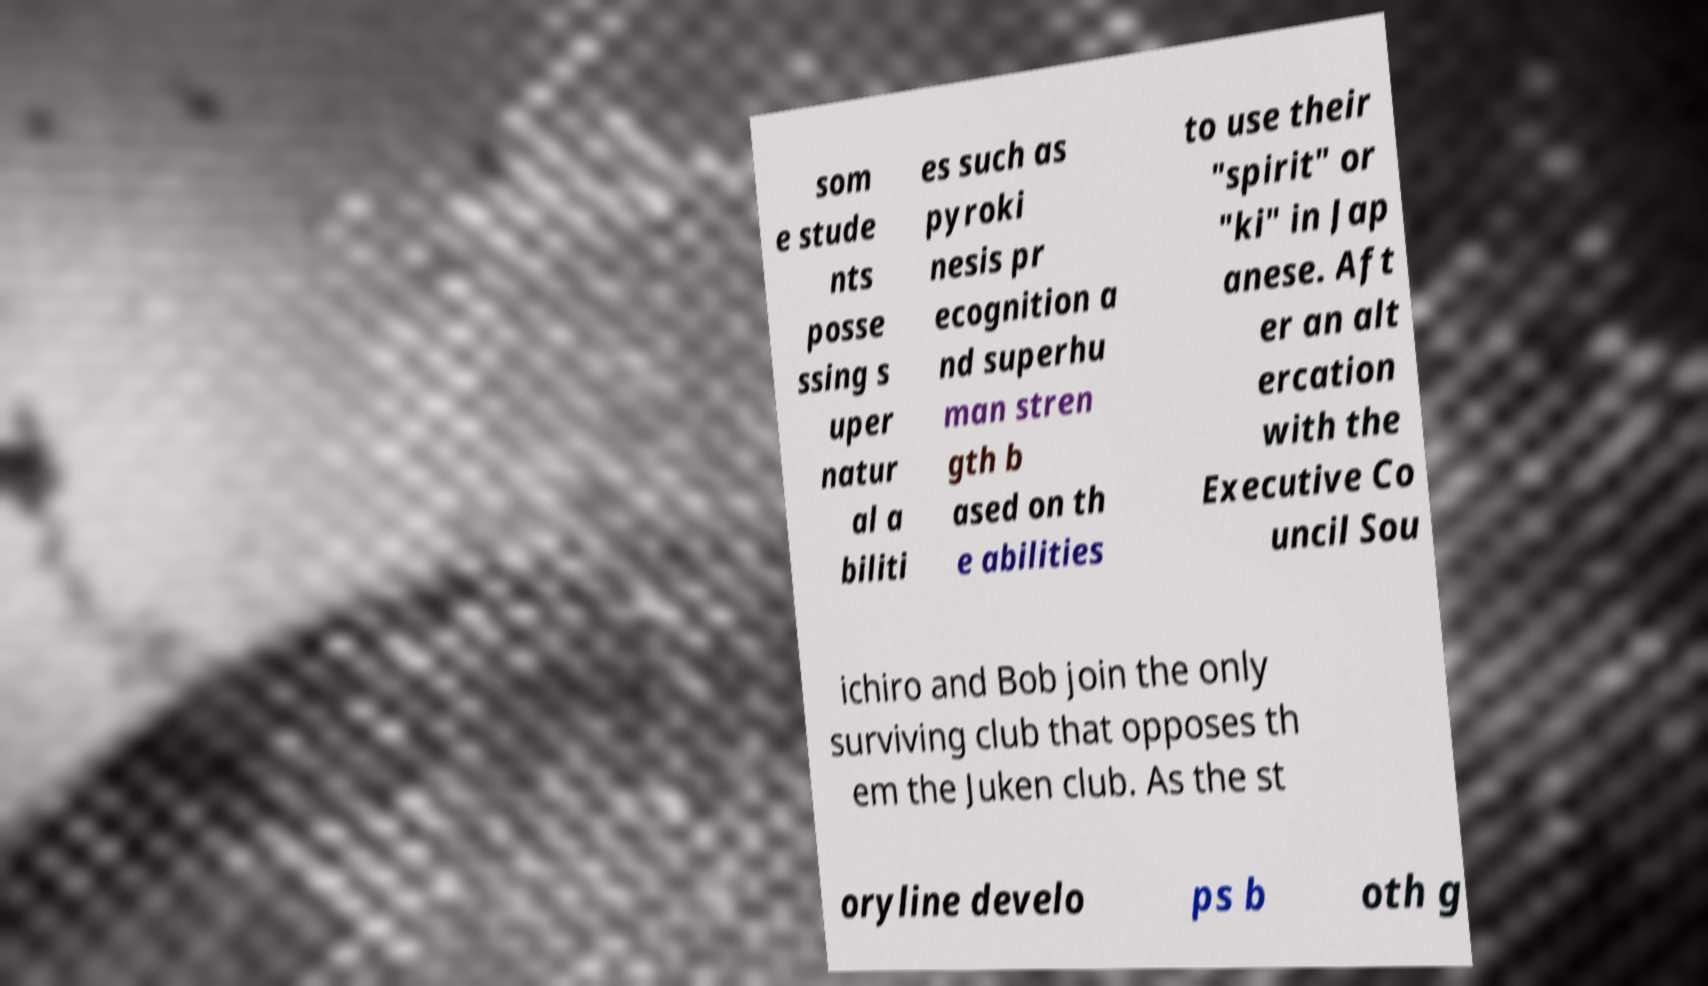Could you extract and type out the text from this image? som e stude nts posse ssing s uper natur al a biliti es such as pyroki nesis pr ecognition a nd superhu man stren gth b ased on th e abilities to use their "spirit" or "ki" in Jap anese. Aft er an alt ercation with the Executive Co uncil Sou ichiro and Bob join the only surviving club that opposes th em the Juken club. As the st oryline develo ps b oth g 